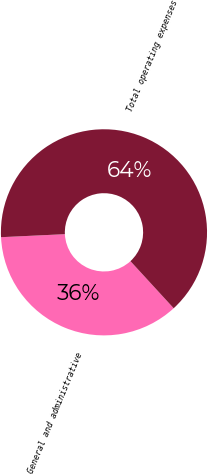Convert chart. <chart><loc_0><loc_0><loc_500><loc_500><pie_chart><fcel>General and administrative<fcel>Total operating expenses<nl><fcel>36.07%<fcel>63.93%<nl></chart> 